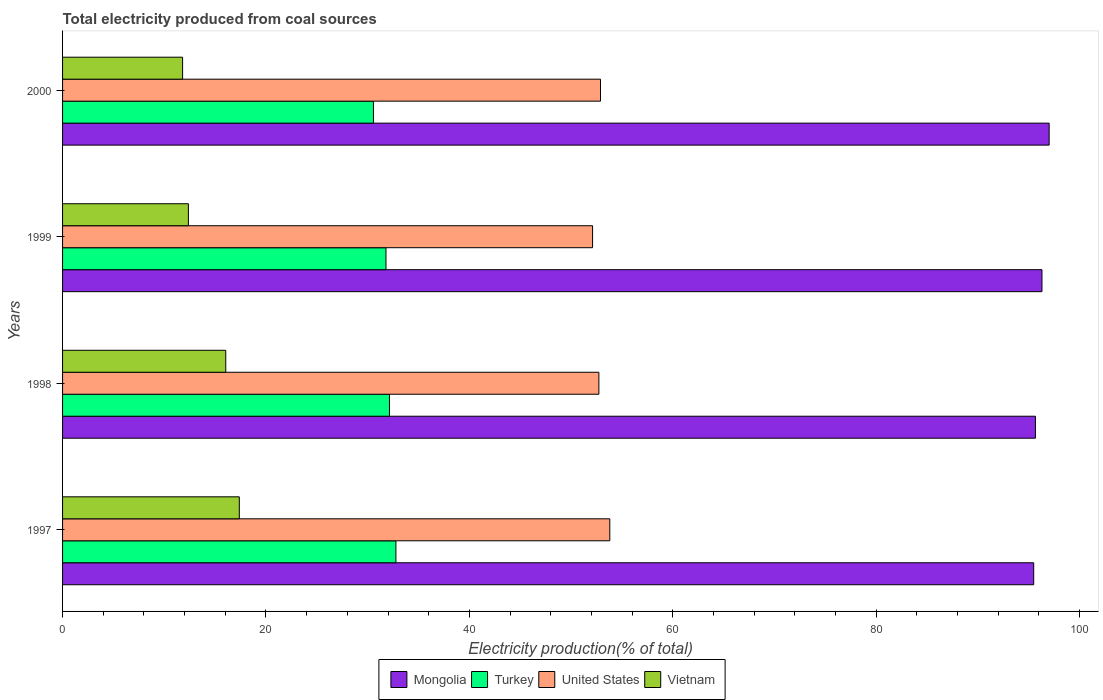How many groups of bars are there?
Offer a very short reply. 4. Are the number of bars per tick equal to the number of legend labels?
Your response must be concise. Yes. Are the number of bars on each tick of the Y-axis equal?
Make the answer very short. Yes. How many bars are there on the 2nd tick from the top?
Your answer should be very brief. 4. How many bars are there on the 3rd tick from the bottom?
Ensure brevity in your answer.  4. In how many cases, is the number of bars for a given year not equal to the number of legend labels?
Give a very brief answer. 0. What is the total electricity produced in Mongolia in 2000?
Provide a succinct answer. 97.01. Across all years, what is the maximum total electricity produced in Mongolia?
Ensure brevity in your answer.  97.01. Across all years, what is the minimum total electricity produced in Vietnam?
Your response must be concise. 11.8. In which year was the total electricity produced in Mongolia minimum?
Offer a terse response. 1997. What is the total total electricity produced in Turkey in the graph?
Make the answer very short. 127.3. What is the difference between the total electricity produced in Mongolia in 1998 and that in 1999?
Your response must be concise. -0.64. What is the difference between the total electricity produced in Mongolia in 2000 and the total electricity produced in Vietnam in 1998?
Offer a very short reply. 80.97. What is the average total electricity produced in Mongolia per year?
Keep it short and to the point. 96.12. In the year 1997, what is the difference between the total electricity produced in Mongolia and total electricity produced in United States?
Give a very brief answer. 41.68. In how many years, is the total electricity produced in Mongolia greater than 64 %?
Keep it short and to the point. 4. What is the ratio of the total electricity produced in Turkey in 1998 to that in 1999?
Make the answer very short. 1.01. Is the total electricity produced in Mongolia in 1998 less than that in 1999?
Your answer should be compact. Yes. Is the difference between the total electricity produced in Mongolia in 1999 and 2000 greater than the difference between the total electricity produced in United States in 1999 and 2000?
Ensure brevity in your answer.  Yes. What is the difference between the highest and the second highest total electricity produced in United States?
Your response must be concise. 0.91. What is the difference between the highest and the lowest total electricity produced in United States?
Ensure brevity in your answer.  1.69. What does the 3rd bar from the bottom in 1997 represents?
Your answer should be compact. United States. Is it the case that in every year, the sum of the total electricity produced in United States and total electricity produced in Turkey is greater than the total electricity produced in Mongolia?
Offer a terse response. No. How many bars are there?
Keep it short and to the point. 16. Are all the bars in the graph horizontal?
Ensure brevity in your answer.  Yes. Does the graph contain grids?
Make the answer very short. No. Where does the legend appear in the graph?
Offer a terse response. Bottom center. How are the legend labels stacked?
Your response must be concise. Horizontal. What is the title of the graph?
Offer a terse response. Total electricity produced from coal sources. What is the Electricity production(% of total) in Mongolia in 1997?
Keep it short and to the point. 95.49. What is the Electricity production(% of total) in Turkey in 1997?
Offer a very short reply. 32.78. What is the Electricity production(% of total) of United States in 1997?
Offer a very short reply. 53.81. What is the Electricity production(% of total) in Vietnam in 1997?
Ensure brevity in your answer.  17.38. What is the Electricity production(% of total) in Mongolia in 1998?
Offer a very short reply. 95.66. What is the Electricity production(% of total) in Turkey in 1998?
Your answer should be compact. 32.14. What is the Electricity production(% of total) in United States in 1998?
Your answer should be very brief. 52.74. What is the Electricity production(% of total) of Vietnam in 1998?
Make the answer very short. 16.05. What is the Electricity production(% of total) in Mongolia in 1999?
Provide a short and direct response. 96.31. What is the Electricity production(% of total) of Turkey in 1999?
Offer a terse response. 31.8. What is the Electricity production(% of total) of United States in 1999?
Give a very brief answer. 52.12. What is the Electricity production(% of total) in Vietnam in 1999?
Ensure brevity in your answer.  12.37. What is the Electricity production(% of total) in Mongolia in 2000?
Offer a terse response. 97.01. What is the Electricity production(% of total) in Turkey in 2000?
Your response must be concise. 30.57. What is the Electricity production(% of total) of United States in 2000?
Give a very brief answer. 52.9. What is the Electricity production(% of total) of Vietnam in 2000?
Provide a short and direct response. 11.8. Across all years, what is the maximum Electricity production(% of total) in Mongolia?
Keep it short and to the point. 97.01. Across all years, what is the maximum Electricity production(% of total) in Turkey?
Your answer should be compact. 32.78. Across all years, what is the maximum Electricity production(% of total) in United States?
Give a very brief answer. 53.81. Across all years, what is the maximum Electricity production(% of total) of Vietnam?
Keep it short and to the point. 17.38. Across all years, what is the minimum Electricity production(% of total) in Mongolia?
Offer a very short reply. 95.49. Across all years, what is the minimum Electricity production(% of total) of Turkey?
Your answer should be very brief. 30.57. Across all years, what is the minimum Electricity production(% of total) of United States?
Offer a very short reply. 52.12. Across all years, what is the minimum Electricity production(% of total) of Vietnam?
Your response must be concise. 11.8. What is the total Electricity production(% of total) in Mongolia in the graph?
Keep it short and to the point. 384.47. What is the total Electricity production(% of total) in Turkey in the graph?
Provide a short and direct response. 127.3. What is the total Electricity production(% of total) of United States in the graph?
Make the answer very short. 211.56. What is the total Electricity production(% of total) in Vietnam in the graph?
Provide a short and direct response. 57.6. What is the difference between the Electricity production(% of total) in Mongolia in 1997 and that in 1998?
Keep it short and to the point. -0.17. What is the difference between the Electricity production(% of total) in Turkey in 1997 and that in 1998?
Your answer should be compact. 0.63. What is the difference between the Electricity production(% of total) in United States in 1997 and that in 1998?
Keep it short and to the point. 1.07. What is the difference between the Electricity production(% of total) in Vietnam in 1997 and that in 1998?
Your answer should be compact. 1.33. What is the difference between the Electricity production(% of total) in Mongolia in 1997 and that in 1999?
Make the answer very short. -0.81. What is the difference between the Electricity production(% of total) in Turkey in 1997 and that in 1999?
Keep it short and to the point. 0.98. What is the difference between the Electricity production(% of total) of United States in 1997 and that in 1999?
Ensure brevity in your answer.  1.69. What is the difference between the Electricity production(% of total) in Vietnam in 1997 and that in 1999?
Give a very brief answer. 5.01. What is the difference between the Electricity production(% of total) in Mongolia in 1997 and that in 2000?
Provide a short and direct response. -1.52. What is the difference between the Electricity production(% of total) in Turkey in 1997 and that in 2000?
Provide a succinct answer. 2.21. What is the difference between the Electricity production(% of total) of United States in 1997 and that in 2000?
Your answer should be very brief. 0.91. What is the difference between the Electricity production(% of total) of Vietnam in 1997 and that in 2000?
Your answer should be compact. 5.58. What is the difference between the Electricity production(% of total) of Mongolia in 1998 and that in 1999?
Your answer should be compact. -0.64. What is the difference between the Electricity production(% of total) in Turkey in 1998 and that in 1999?
Your answer should be very brief. 0.34. What is the difference between the Electricity production(% of total) in United States in 1998 and that in 1999?
Your answer should be compact. 0.62. What is the difference between the Electricity production(% of total) of Vietnam in 1998 and that in 1999?
Offer a very short reply. 3.67. What is the difference between the Electricity production(% of total) of Mongolia in 1998 and that in 2000?
Keep it short and to the point. -1.35. What is the difference between the Electricity production(% of total) in Turkey in 1998 and that in 2000?
Give a very brief answer. 1.58. What is the difference between the Electricity production(% of total) of United States in 1998 and that in 2000?
Your answer should be compact. -0.16. What is the difference between the Electricity production(% of total) of Vietnam in 1998 and that in 2000?
Your answer should be very brief. 4.24. What is the difference between the Electricity production(% of total) of Mongolia in 1999 and that in 2000?
Offer a terse response. -0.71. What is the difference between the Electricity production(% of total) in Turkey in 1999 and that in 2000?
Ensure brevity in your answer.  1.23. What is the difference between the Electricity production(% of total) in United States in 1999 and that in 2000?
Offer a terse response. -0.78. What is the difference between the Electricity production(% of total) of Vietnam in 1999 and that in 2000?
Keep it short and to the point. 0.57. What is the difference between the Electricity production(% of total) of Mongolia in 1997 and the Electricity production(% of total) of Turkey in 1998?
Keep it short and to the point. 63.35. What is the difference between the Electricity production(% of total) of Mongolia in 1997 and the Electricity production(% of total) of United States in 1998?
Offer a very short reply. 42.76. What is the difference between the Electricity production(% of total) in Mongolia in 1997 and the Electricity production(% of total) in Vietnam in 1998?
Keep it short and to the point. 79.45. What is the difference between the Electricity production(% of total) in Turkey in 1997 and the Electricity production(% of total) in United States in 1998?
Offer a terse response. -19.96. What is the difference between the Electricity production(% of total) of Turkey in 1997 and the Electricity production(% of total) of Vietnam in 1998?
Provide a succinct answer. 16.73. What is the difference between the Electricity production(% of total) of United States in 1997 and the Electricity production(% of total) of Vietnam in 1998?
Your answer should be very brief. 37.76. What is the difference between the Electricity production(% of total) in Mongolia in 1997 and the Electricity production(% of total) in Turkey in 1999?
Ensure brevity in your answer.  63.69. What is the difference between the Electricity production(% of total) in Mongolia in 1997 and the Electricity production(% of total) in United States in 1999?
Make the answer very short. 43.38. What is the difference between the Electricity production(% of total) in Mongolia in 1997 and the Electricity production(% of total) in Vietnam in 1999?
Provide a short and direct response. 83.12. What is the difference between the Electricity production(% of total) of Turkey in 1997 and the Electricity production(% of total) of United States in 1999?
Provide a succinct answer. -19.34. What is the difference between the Electricity production(% of total) in Turkey in 1997 and the Electricity production(% of total) in Vietnam in 1999?
Offer a very short reply. 20.41. What is the difference between the Electricity production(% of total) in United States in 1997 and the Electricity production(% of total) in Vietnam in 1999?
Give a very brief answer. 41.44. What is the difference between the Electricity production(% of total) in Mongolia in 1997 and the Electricity production(% of total) in Turkey in 2000?
Keep it short and to the point. 64.92. What is the difference between the Electricity production(% of total) of Mongolia in 1997 and the Electricity production(% of total) of United States in 2000?
Give a very brief answer. 42.6. What is the difference between the Electricity production(% of total) in Mongolia in 1997 and the Electricity production(% of total) in Vietnam in 2000?
Your answer should be very brief. 83.69. What is the difference between the Electricity production(% of total) in Turkey in 1997 and the Electricity production(% of total) in United States in 2000?
Keep it short and to the point. -20.12. What is the difference between the Electricity production(% of total) in Turkey in 1997 and the Electricity production(% of total) in Vietnam in 2000?
Offer a very short reply. 20.98. What is the difference between the Electricity production(% of total) of United States in 1997 and the Electricity production(% of total) of Vietnam in 2000?
Offer a terse response. 42.01. What is the difference between the Electricity production(% of total) in Mongolia in 1998 and the Electricity production(% of total) in Turkey in 1999?
Give a very brief answer. 63.86. What is the difference between the Electricity production(% of total) of Mongolia in 1998 and the Electricity production(% of total) of United States in 1999?
Offer a terse response. 43.55. What is the difference between the Electricity production(% of total) of Mongolia in 1998 and the Electricity production(% of total) of Vietnam in 1999?
Ensure brevity in your answer.  83.29. What is the difference between the Electricity production(% of total) in Turkey in 1998 and the Electricity production(% of total) in United States in 1999?
Give a very brief answer. -19.97. What is the difference between the Electricity production(% of total) of Turkey in 1998 and the Electricity production(% of total) of Vietnam in 1999?
Give a very brief answer. 19.77. What is the difference between the Electricity production(% of total) in United States in 1998 and the Electricity production(% of total) in Vietnam in 1999?
Make the answer very short. 40.36. What is the difference between the Electricity production(% of total) in Mongolia in 1998 and the Electricity production(% of total) in Turkey in 2000?
Your response must be concise. 65.09. What is the difference between the Electricity production(% of total) in Mongolia in 1998 and the Electricity production(% of total) in United States in 2000?
Provide a short and direct response. 42.77. What is the difference between the Electricity production(% of total) of Mongolia in 1998 and the Electricity production(% of total) of Vietnam in 2000?
Offer a very short reply. 83.86. What is the difference between the Electricity production(% of total) in Turkey in 1998 and the Electricity production(% of total) in United States in 2000?
Provide a succinct answer. -20.75. What is the difference between the Electricity production(% of total) of Turkey in 1998 and the Electricity production(% of total) of Vietnam in 2000?
Make the answer very short. 20.34. What is the difference between the Electricity production(% of total) in United States in 1998 and the Electricity production(% of total) in Vietnam in 2000?
Make the answer very short. 40.93. What is the difference between the Electricity production(% of total) of Mongolia in 1999 and the Electricity production(% of total) of Turkey in 2000?
Your answer should be compact. 65.74. What is the difference between the Electricity production(% of total) of Mongolia in 1999 and the Electricity production(% of total) of United States in 2000?
Your answer should be compact. 43.41. What is the difference between the Electricity production(% of total) of Mongolia in 1999 and the Electricity production(% of total) of Vietnam in 2000?
Your answer should be very brief. 84.5. What is the difference between the Electricity production(% of total) of Turkey in 1999 and the Electricity production(% of total) of United States in 2000?
Offer a terse response. -21.09. What is the difference between the Electricity production(% of total) of Turkey in 1999 and the Electricity production(% of total) of Vietnam in 2000?
Make the answer very short. 20. What is the difference between the Electricity production(% of total) of United States in 1999 and the Electricity production(% of total) of Vietnam in 2000?
Your response must be concise. 40.31. What is the average Electricity production(% of total) in Mongolia per year?
Ensure brevity in your answer.  96.12. What is the average Electricity production(% of total) in Turkey per year?
Ensure brevity in your answer.  31.82. What is the average Electricity production(% of total) in United States per year?
Make the answer very short. 52.89. What is the average Electricity production(% of total) of Vietnam per year?
Give a very brief answer. 14.4. In the year 1997, what is the difference between the Electricity production(% of total) in Mongolia and Electricity production(% of total) in Turkey?
Your response must be concise. 62.71. In the year 1997, what is the difference between the Electricity production(% of total) in Mongolia and Electricity production(% of total) in United States?
Your response must be concise. 41.68. In the year 1997, what is the difference between the Electricity production(% of total) of Mongolia and Electricity production(% of total) of Vietnam?
Offer a terse response. 78.11. In the year 1997, what is the difference between the Electricity production(% of total) of Turkey and Electricity production(% of total) of United States?
Provide a short and direct response. -21.03. In the year 1997, what is the difference between the Electricity production(% of total) of Turkey and Electricity production(% of total) of Vietnam?
Make the answer very short. 15.4. In the year 1997, what is the difference between the Electricity production(% of total) of United States and Electricity production(% of total) of Vietnam?
Provide a succinct answer. 36.43. In the year 1998, what is the difference between the Electricity production(% of total) in Mongolia and Electricity production(% of total) in Turkey?
Your answer should be compact. 63.52. In the year 1998, what is the difference between the Electricity production(% of total) in Mongolia and Electricity production(% of total) in United States?
Keep it short and to the point. 42.93. In the year 1998, what is the difference between the Electricity production(% of total) in Mongolia and Electricity production(% of total) in Vietnam?
Ensure brevity in your answer.  79.62. In the year 1998, what is the difference between the Electricity production(% of total) in Turkey and Electricity production(% of total) in United States?
Your response must be concise. -20.59. In the year 1998, what is the difference between the Electricity production(% of total) in Turkey and Electricity production(% of total) in Vietnam?
Offer a very short reply. 16.1. In the year 1998, what is the difference between the Electricity production(% of total) in United States and Electricity production(% of total) in Vietnam?
Offer a very short reply. 36.69. In the year 1999, what is the difference between the Electricity production(% of total) of Mongolia and Electricity production(% of total) of Turkey?
Your response must be concise. 64.5. In the year 1999, what is the difference between the Electricity production(% of total) in Mongolia and Electricity production(% of total) in United States?
Make the answer very short. 44.19. In the year 1999, what is the difference between the Electricity production(% of total) in Mongolia and Electricity production(% of total) in Vietnam?
Give a very brief answer. 83.93. In the year 1999, what is the difference between the Electricity production(% of total) of Turkey and Electricity production(% of total) of United States?
Your response must be concise. -20.31. In the year 1999, what is the difference between the Electricity production(% of total) of Turkey and Electricity production(% of total) of Vietnam?
Give a very brief answer. 19.43. In the year 1999, what is the difference between the Electricity production(% of total) in United States and Electricity production(% of total) in Vietnam?
Provide a short and direct response. 39.74. In the year 2000, what is the difference between the Electricity production(% of total) of Mongolia and Electricity production(% of total) of Turkey?
Provide a short and direct response. 66.44. In the year 2000, what is the difference between the Electricity production(% of total) of Mongolia and Electricity production(% of total) of United States?
Provide a short and direct response. 44.12. In the year 2000, what is the difference between the Electricity production(% of total) of Mongolia and Electricity production(% of total) of Vietnam?
Offer a very short reply. 85.21. In the year 2000, what is the difference between the Electricity production(% of total) of Turkey and Electricity production(% of total) of United States?
Offer a very short reply. -22.33. In the year 2000, what is the difference between the Electricity production(% of total) of Turkey and Electricity production(% of total) of Vietnam?
Your answer should be compact. 18.77. In the year 2000, what is the difference between the Electricity production(% of total) in United States and Electricity production(% of total) in Vietnam?
Offer a terse response. 41.09. What is the ratio of the Electricity production(% of total) in Mongolia in 1997 to that in 1998?
Keep it short and to the point. 1. What is the ratio of the Electricity production(% of total) of Turkey in 1997 to that in 1998?
Your response must be concise. 1.02. What is the ratio of the Electricity production(% of total) of United States in 1997 to that in 1998?
Your answer should be compact. 1.02. What is the ratio of the Electricity production(% of total) in Vietnam in 1997 to that in 1998?
Give a very brief answer. 1.08. What is the ratio of the Electricity production(% of total) of Mongolia in 1997 to that in 1999?
Your answer should be very brief. 0.99. What is the ratio of the Electricity production(% of total) of Turkey in 1997 to that in 1999?
Your answer should be very brief. 1.03. What is the ratio of the Electricity production(% of total) of United States in 1997 to that in 1999?
Offer a terse response. 1.03. What is the ratio of the Electricity production(% of total) in Vietnam in 1997 to that in 1999?
Keep it short and to the point. 1.4. What is the ratio of the Electricity production(% of total) of Mongolia in 1997 to that in 2000?
Your response must be concise. 0.98. What is the ratio of the Electricity production(% of total) of Turkey in 1997 to that in 2000?
Keep it short and to the point. 1.07. What is the ratio of the Electricity production(% of total) in United States in 1997 to that in 2000?
Your answer should be compact. 1.02. What is the ratio of the Electricity production(% of total) of Vietnam in 1997 to that in 2000?
Provide a succinct answer. 1.47. What is the ratio of the Electricity production(% of total) of Turkey in 1998 to that in 1999?
Your answer should be compact. 1.01. What is the ratio of the Electricity production(% of total) of United States in 1998 to that in 1999?
Provide a short and direct response. 1.01. What is the ratio of the Electricity production(% of total) in Vietnam in 1998 to that in 1999?
Keep it short and to the point. 1.3. What is the ratio of the Electricity production(% of total) of Mongolia in 1998 to that in 2000?
Your answer should be compact. 0.99. What is the ratio of the Electricity production(% of total) in Turkey in 1998 to that in 2000?
Ensure brevity in your answer.  1.05. What is the ratio of the Electricity production(% of total) of United States in 1998 to that in 2000?
Your response must be concise. 1. What is the ratio of the Electricity production(% of total) in Vietnam in 1998 to that in 2000?
Provide a short and direct response. 1.36. What is the ratio of the Electricity production(% of total) of Mongolia in 1999 to that in 2000?
Give a very brief answer. 0.99. What is the ratio of the Electricity production(% of total) in Turkey in 1999 to that in 2000?
Ensure brevity in your answer.  1.04. What is the ratio of the Electricity production(% of total) in Vietnam in 1999 to that in 2000?
Your answer should be very brief. 1.05. What is the difference between the highest and the second highest Electricity production(% of total) in Mongolia?
Your answer should be compact. 0.71. What is the difference between the highest and the second highest Electricity production(% of total) in Turkey?
Make the answer very short. 0.63. What is the difference between the highest and the second highest Electricity production(% of total) in United States?
Ensure brevity in your answer.  0.91. What is the difference between the highest and the second highest Electricity production(% of total) in Vietnam?
Offer a terse response. 1.33. What is the difference between the highest and the lowest Electricity production(% of total) in Mongolia?
Offer a terse response. 1.52. What is the difference between the highest and the lowest Electricity production(% of total) in Turkey?
Your answer should be very brief. 2.21. What is the difference between the highest and the lowest Electricity production(% of total) of United States?
Your response must be concise. 1.69. What is the difference between the highest and the lowest Electricity production(% of total) of Vietnam?
Ensure brevity in your answer.  5.58. 